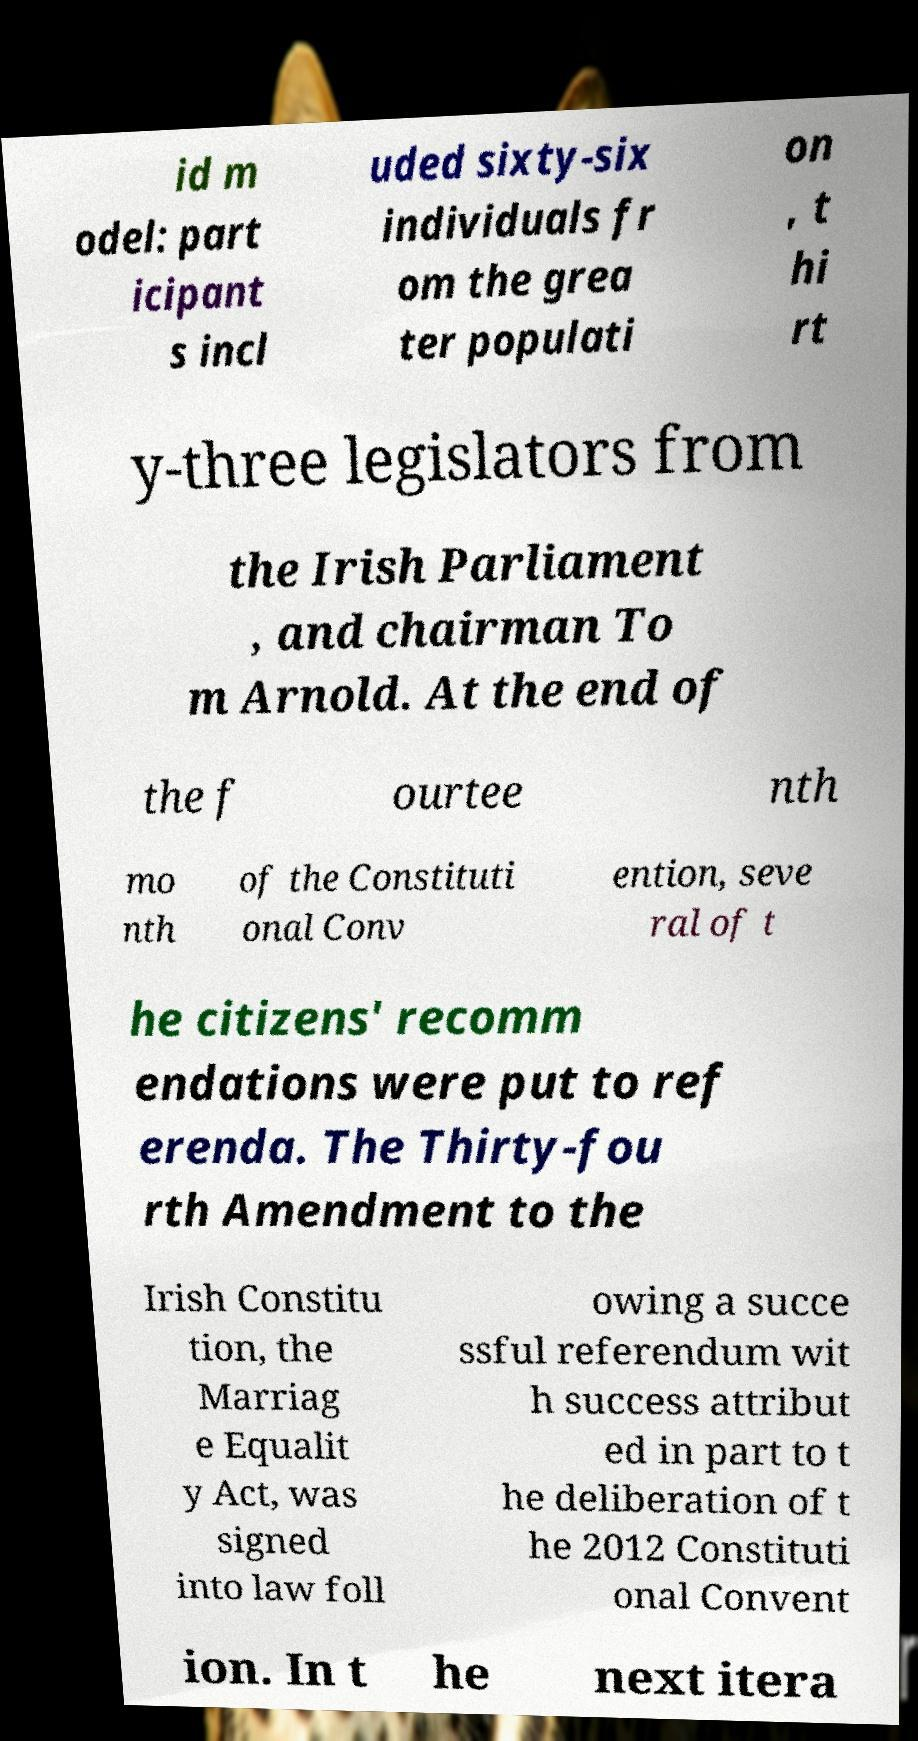Could you extract and type out the text from this image? id m odel: part icipant s incl uded sixty-six individuals fr om the grea ter populati on , t hi rt y-three legislators from the Irish Parliament , and chairman To m Arnold. At the end of the f ourtee nth mo nth of the Constituti onal Conv ention, seve ral of t he citizens' recomm endations were put to ref erenda. The Thirty-fou rth Amendment to the Irish Constitu tion, the Marriag e Equalit y Act, was signed into law foll owing a succe ssful referendum wit h success attribut ed in part to t he deliberation of t he 2012 Constituti onal Convent ion. In t he next itera 